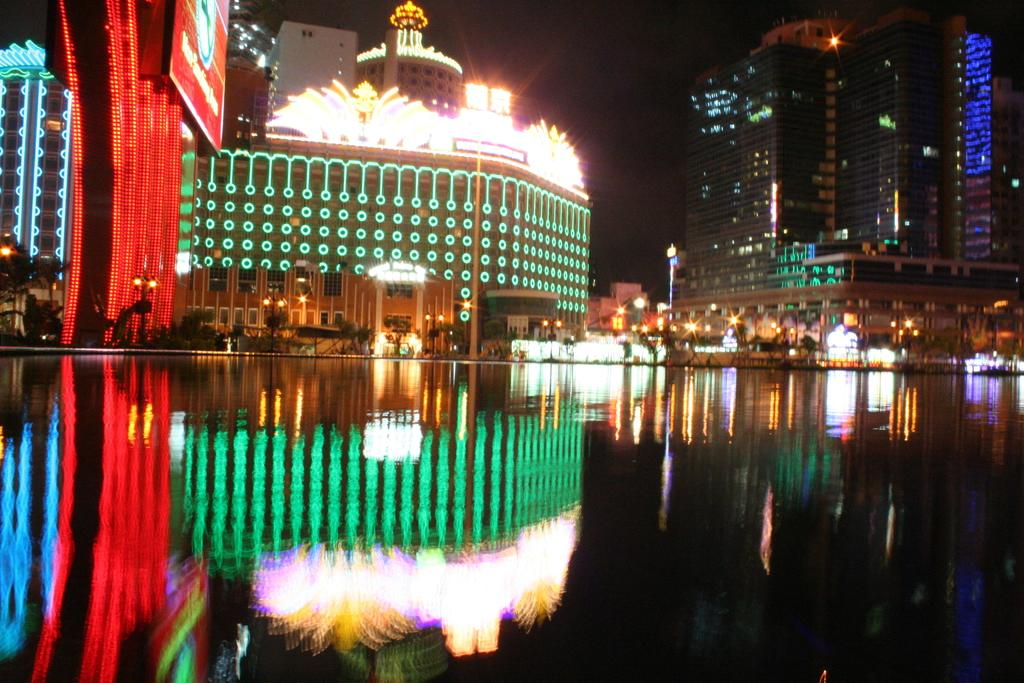What type of structures are illuminated in the image? There is a group of buildings with lights in the image. What else can be seen in the image besides the buildings? There are poles, a large water body, trees, and the sky visible in the image. What type of sign can be seen hanging from the trees in the image? There is no sign present in the image; it only features a group of buildings with lights, poles, a large water body, trees, and the sky. 